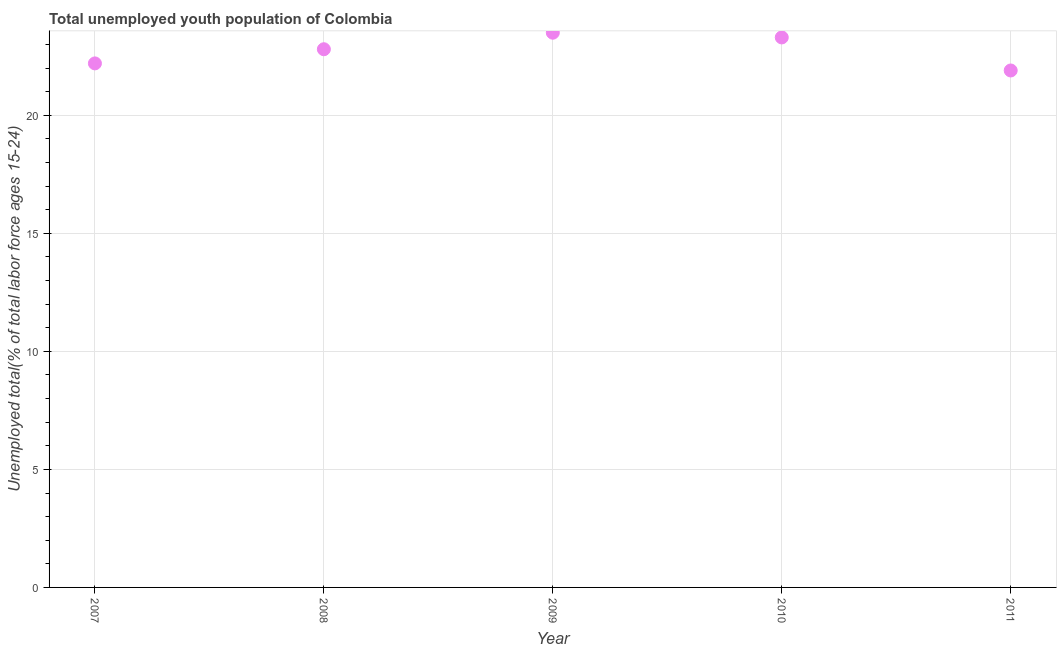What is the unemployed youth in 2007?
Ensure brevity in your answer.  22.2. Across all years, what is the maximum unemployed youth?
Provide a succinct answer. 23.5. Across all years, what is the minimum unemployed youth?
Your answer should be compact. 21.9. In which year was the unemployed youth minimum?
Give a very brief answer. 2011. What is the sum of the unemployed youth?
Keep it short and to the point. 113.7. What is the difference between the unemployed youth in 2008 and 2009?
Your answer should be compact. -0.7. What is the average unemployed youth per year?
Provide a succinct answer. 22.74. What is the median unemployed youth?
Your answer should be very brief. 22.8. In how many years, is the unemployed youth greater than 9 %?
Keep it short and to the point. 5. What is the ratio of the unemployed youth in 2007 to that in 2011?
Provide a succinct answer. 1.01. Is the unemployed youth in 2007 less than that in 2010?
Ensure brevity in your answer.  Yes. What is the difference between the highest and the second highest unemployed youth?
Your answer should be compact. 0.2. What is the difference between the highest and the lowest unemployed youth?
Provide a short and direct response. 1.6. In how many years, is the unemployed youth greater than the average unemployed youth taken over all years?
Make the answer very short. 3. Does the unemployed youth monotonically increase over the years?
Make the answer very short. No. How many dotlines are there?
Provide a short and direct response. 1. How many years are there in the graph?
Your response must be concise. 5. Does the graph contain grids?
Offer a very short reply. Yes. What is the title of the graph?
Keep it short and to the point. Total unemployed youth population of Colombia. What is the label or title of the X-axis?
Your answer should be very brief. Year. What is the label or title of the Y-axis?
Give a very brief answer. Unemployed total(% of total labor force ages 15-24). What is the Unemployed total(% of total labor force ages 15-24) in 2007?
Keep it short and to the point. 22.2. What is the Unemployed total(% of total labor force ages 15-24) in 2008?
Offer a very short reply. 22.8. What is the Unemployed total(% of total labor force ages 15-24) in 2009?
Your response must be concise. 23.5. What is the Unemployed total(% of total labor force ages 15-24) in 2010?
Make the answer very short. 23.3. What is the Unemployed total(% of total labor force ages 15-24) in 2011?
Keep it short and to the point. 21.9. What is the difference between the Unemployed total(% of total labor force ages 15-24) in 2007 and 2008?
Provide a short and direct response. -0.6. What is the difference between the Unemployed total(% of total labor force ages 15-24) in 2008 and 2009?
Your answer should be compact. -0.7. What is the difference between the Unemployed total(% of total labor force ages 15-24) in 2008 and 2011?
Your answer should be compact. 0.9. What is the difference between the Unemployed total(% of total labor force ages 15-24) in 2009 and 2011?
Offer a very short reply. 1.6. What is the difference between the Unemployed total(% of total labor force ages 15-24) in 2010 and 2011?
Give a very brief answer. 1.4. What is the ratio of the Unemployed total(% of total labor force ages 15-24) in 2007 to that in 2008?
Offer a very short reply. 0.97. What is the ratio of the Unemployed total(% of total labor force ages 15-24) in 2007 to that in 2009?
Ensure brevity in your answer.  0.94. What is the ratio of the Unemployed total(% of total labor force ages 15-24) in 2007 to that in 2010?
Your response must be concise. 0.95. What is the ratio of the Unemployed total(% of total labor force ages 15-24) in 2007 to that in 2011?
Provide a short and direct response. 1.01. What is the ratio of the Unemployed total(% of total labor force ages 15-24) in 2008 to that in 2009?
Give a very brief answer. 0.97. What is the ratio of the Unemployed total(% of total labor force ages 15-24) in 2008 to that in 2011?
Make the answer very short. 1.04. What is the ratio of the Unemployed total(% of total labor force ages 15-24) in 2009 to that in 2010?
Keep it short and to the point. 1.01. What is the ratio of the Unemployed total(% of total labor force ages 15-24) in 2009 to that in 2011?
Your answer should be very brief. 1.07. What is the ratio of the Unemployed total(% of total labor force ages 15-24) in 2010 to that in 2011?
Offer a terse response. 1.06. 